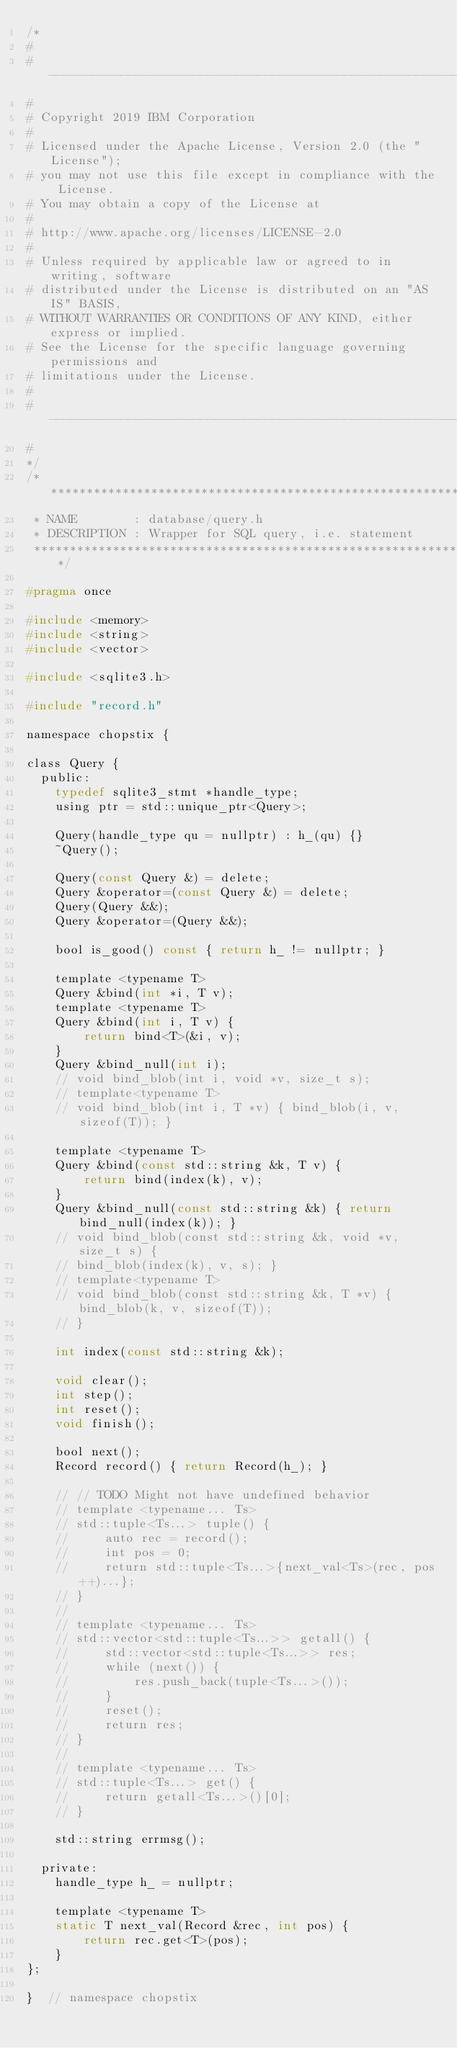Convert code to text. <code><loc_0><loc_0><loc_500><loc_500><_C_>/*
#
# ----------------------------------------------------------------------------
#
# Copyright 2019 IBM Corporation
#
# Licensed under the Apache License, Version 2.0 (the "License");
# you may not use this file except in compliance with the License.
# You may obtain a copy of the License at
#
# http://www.apache.org/licenses/LICENSE-2.0
#
# Unless required by applicable law or agreed to in writing, software
# distributed under the License is distributed on an "AS IS" BASIS,
# WITHOUT WARRANTIES OR CONDITIONS OF ANY KIND, either express or implied.
# See the License for the specific language governing permissions and
# limitations under the License.
#
# ----------------------------------------------------------------------------
#
*/
/******************************************************************************
 * NAME        : database/query.h
 * DESCRIPTION : Wrapper for SQL query, i.e. statement
 ******************************************************************************/

#pragma once

#include <memory>
#include <string>
#include <vector>

#include <sqlite3.h>

#include "record.h"

namespace chopstix {

class Query {
  public:
    typedef sqlite3_stmt *handle_type;
    using ptr = std::unique_ptr<Query>;

    Query(handle_type qu = nullptr) : h_(qu) {}
    ~Query();

    Query(const Query &) = delete;
    Query &operator=(const Query &) = delete;
    Query(Query &&);
    Query &operator=(Query &&);

    bool is_good() const { return h_ != nullptr; }

    template <typename T>
    Query &bind(int *i, T v);
    template <typename T>
    Query &bind(int i, T v) {
        return bind<T>(&i, v);
    }
    Query &bind_null(int i);
    // void bind_blob(int i, void *v, size_t s);
    // template<typename T>
    // void bind_blob(int i, T *v) { bind_blob(i, v, sizeof(T)); }

    template <typename T>
    Query &bind(const std::string &k, T v) {
        return bind(index(k), v);
    }
    Query &bind_null(const std::string &k) { return bind_null(index(k)); }
    // void bind_blob(const std::string &k, void *v, size_t s) {
    // bind_blob(index(k), v, s); }
    // template<typename T>
    // void bind_blob(const std::string &k, T *v) { bind_blob(k, v, sizeof(T));
    // }

    int index(const std::string &k);

    void clear();
    int step();
    int reset();
    void finish();

    bool next();
    Record record() { return Record(h_); }

    // // TODO Might not have undefined behavior
    // template <typename... Ts>
    // std::tuple<Ts...> tuple() {
    //     auto rec = record();
    //     int pos = 0;
    //     return std::tuple<Ts...>{next_val<Ts>(rec, pos++)...};
    // }
    //
    // template <typename... Ts>
    // std::vector<std::tuple<Ts...>> getall() {
    //     std::vector<std::tuple<Ts...>> res;
    //     while (next()) {
    //         res.push_back(tuple<Ts...>());
    //     }
    //     reset();
    //     return res;
    // }
    //
    // template <typename... Ts>
    // std::tuple<Ts...> get() {
    //     return getall<Ts...>()[0];
    // }

    std::string errmsg();

  private:
    handle_type h_ = nullptr;

    template <typename T>
    static T next_val(Record &rec, int pos) {
        return rec.get<T>(pos);
    }
};

}  // namespace chopstix
</code> 